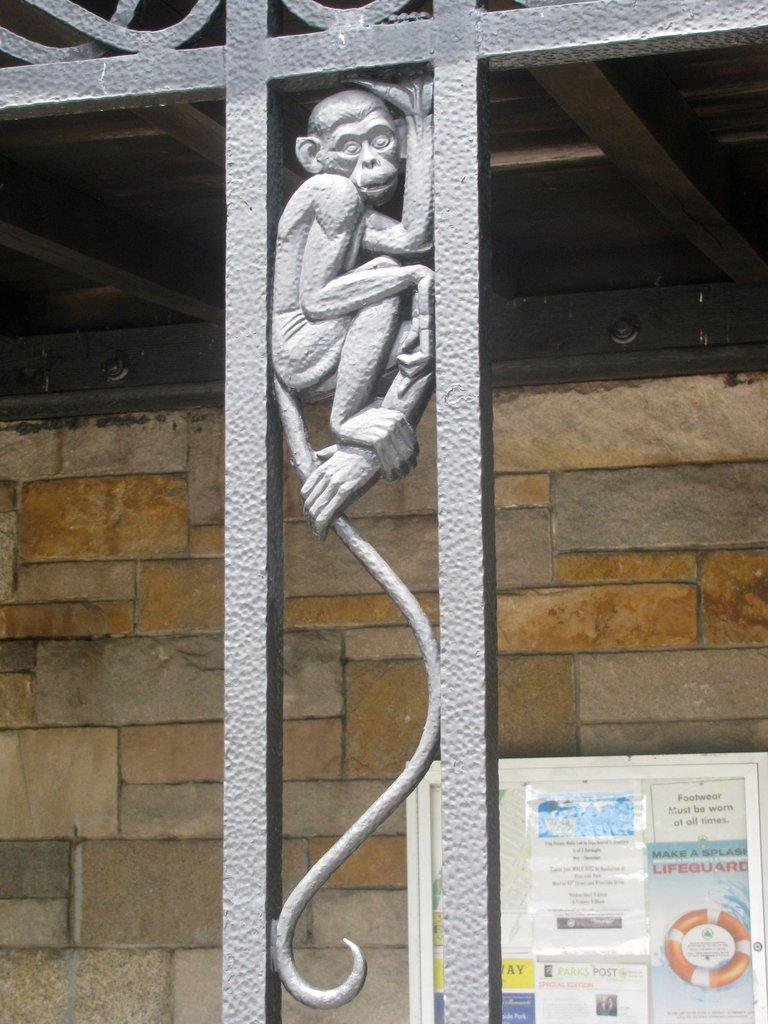What is located in the center of the image? There is a metal fence in the center of the image. What can be seen within the metal fence? There is a monkey sculpture in the metal fence. What is visible in the background of the image? There is a wall, a roof, and a banner in the background of the image. What type of zinc is used to create the monkey sculpture in the image? There is no mention of zinc being used in the image, and the monkey sculpture is made of metal, not zinc. How does the snake interact with the metal fence in the image? There is no snake present in the image, so it cannot interact with the metal fence. 